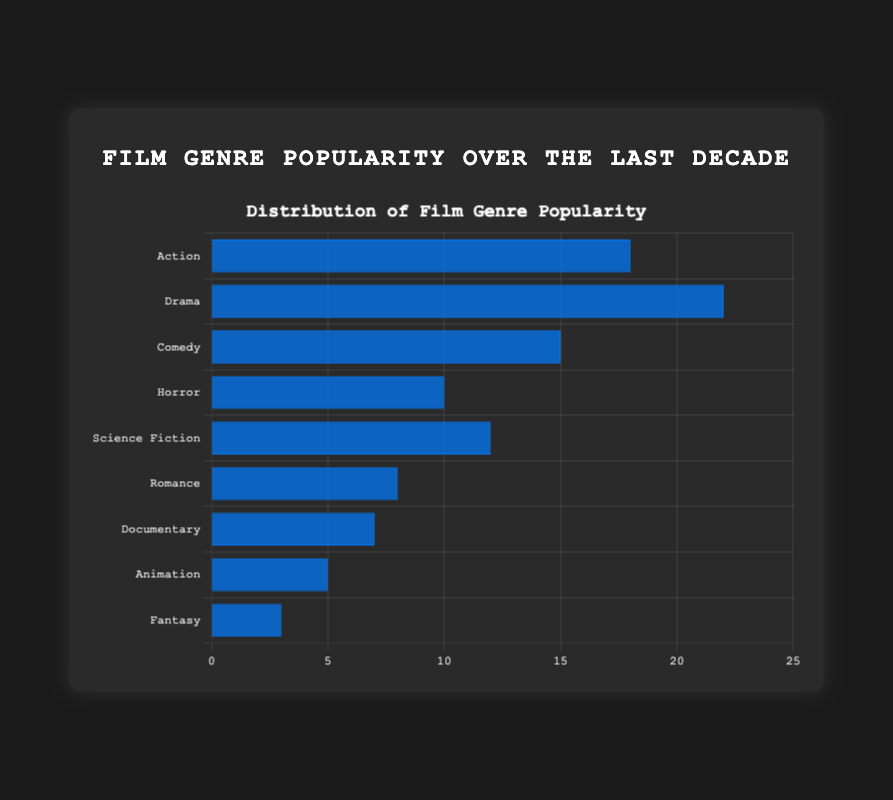What film genre has the highest popularity percentage? The bar chart shows the popularity percentage for each genre, and Drama has the highest bar.
Answer: Drama Which two genres have the smallest difference in their popularity percentages, and what is that difference? Identify the two genres with the closest popularity percentages. Action (18%) and Science Fiction (12%) have a difference of 18 - 12 = 6.
Answer: Action and Science Fiction, 6% What is the sum of the popularity percentages for Comedy, Horror, and Documentary? Adding the popularity percentages: Comedy (15%) + Horror (10%) + Documentary (7%) = 15 + 10 + 7 = 32
Answer: 32% Compare the popularity of Action and Romance genres. Which is more popular and by how much? Action has a popularity of 18%, and Romance has 8%. Subtract them: 18 - 8 = 10.
Answer: Action is more popular by 10% Among Horror, Science Fiction, Romance, and Documentary, which genre has the lowest popularity? Compare the percentages: Horror (10%), Science Fiction (12%), Romance (8%), Documentary (7%). Documentary is the lowest.
Answer: Documentary What's the average popularity percentage for Action, Drama, and Comedy? Calculate the average: (18 + 22 + 15) / 3 = 55 / 3 ≈ 18.33
Answer: 18.33% Which genre stands out by having the lowest popularity percentage? Identify the genre with the lowest percentage, which is Fantasy at 3%.
Answer: Fantasy How much more popular is Comedy compared to Animation? Comedy has 15%, and Animation has 5%. Subtract to find the difference: 15 - 5 = 10.
Answer: 10% Identify the genres whose popularity percentages are in single digits. How many are there? The genres with single-digit percentages are Romance (8%), Documentary (7%), Animation (5%), and Fantasy (3%). There are four.
Answer: Four By how much is Drama more popular than the average popularity of Horror and Science Fiction? First, find the average: (10 + 12) / 2 = 11. Then subtract from Drama's percentage: 22 - 11 = 11.
Answer: 11% 